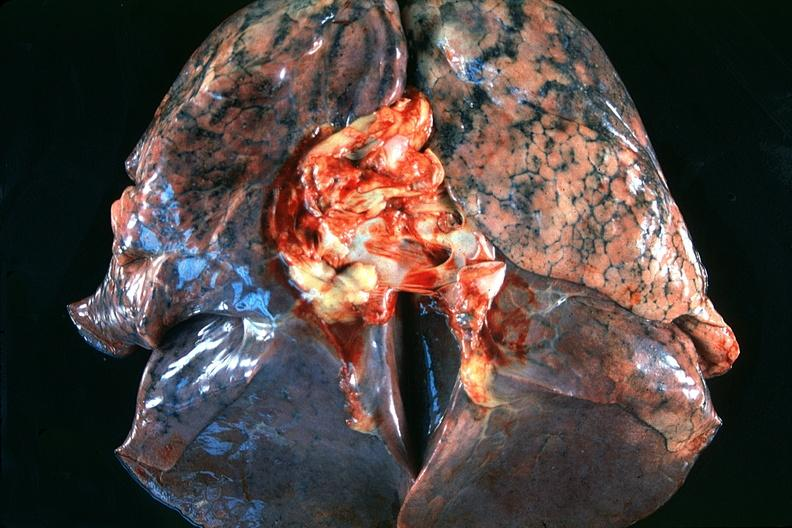where is this?
Answer the question using a single word or phrase. Lung 